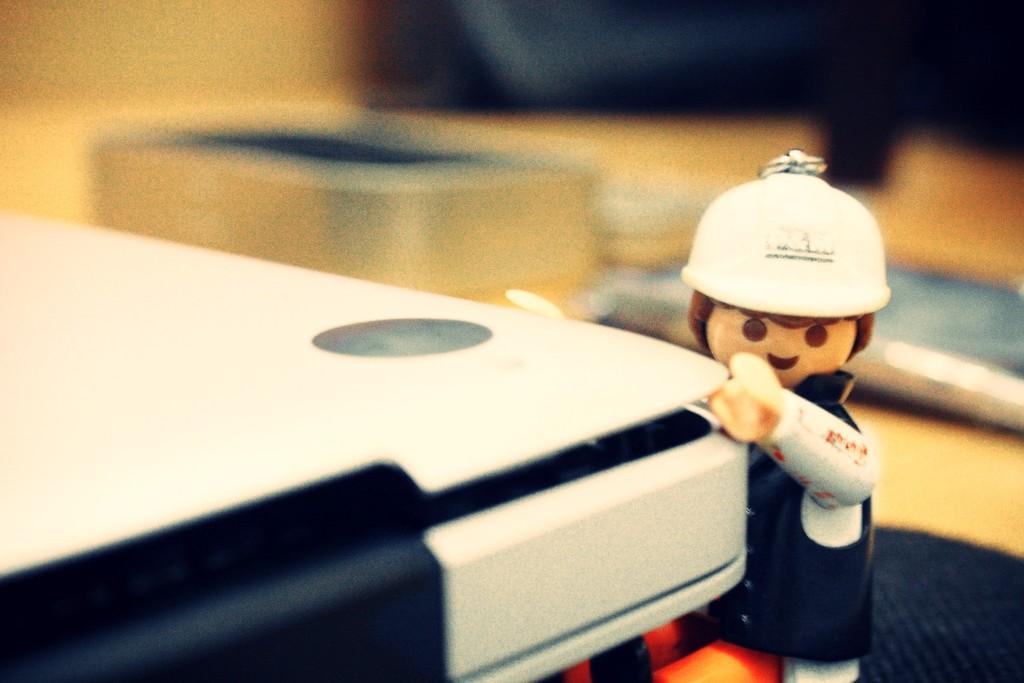In one or two sentences, can you explain what this image depicts? In this picture we can see toy and objects. Background it is blur. 